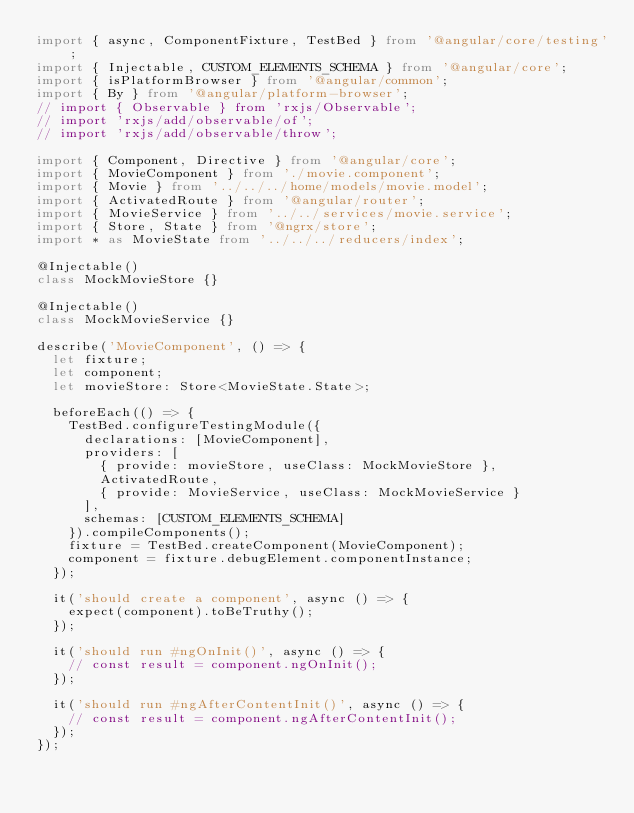Convert code to text. <code><loc_0><loc_0><loc_500><loc_500><_TypeScript_>import { async, ComponentFixture, TestBed } from '@angular/core/testing';
import { Injectable, CUSTOM_ELEMENTS_SCHEMA } from '@angular/core';
import { isPlatformBrowser } from '@angular/common';
import { By } from '@angular/platform-browser';
// import { Observable } from 'rxjs/Observable';
// import 'rxjs/add/observable/of';
// import 'rxjs/add/observable/throw';

import { Component, Directive } from '@angular/core';
import { MovieComponent } from './movie.component';
import { Movie } from '../../../home/models/movie.model';
import { ActivatedRoute } from '@angular/router';
import { MovieService } from '../../services/movie.service';
import { Store, State } from '@ngrx/store';
import * as MovieState from '../../../reducers/index';

@Injectable()
class MockMovieStore {}

@Injectable()
class MockMovieService {}

describe('MovieComponent', () => {
  let fixture;
  let component;
  let movieStore: Store<MovieState.State>;

  beforeEach(() => {
    TestBed.configureTestingModule({
      declarations: [MovieComponent],
      providers: [
        { provide: movieStore, useClass: MockMovieStore },
        ActivatedRoute,
        { provide: MovieService, useClass: MockMovieService }
      ],
      schemas: [CUSTOM_ELEMENTS_SCHEMA]
    }).compileComponents();
    fixture = TestBed.createComponent(MovieComponent);
    component = fixture.debugElement.componentInstance;
  });

  it('should create a component', async () => {
    expect(component).toBeTruthy();
  });

  it('should run #ngOnInit()', async () => {
    // const result = component.ngOnInit();
  });

  it('should run #ngAfterContentInit()', async () => {
    // const result = component.ngAfterContentInit();
  });
});
</code> 